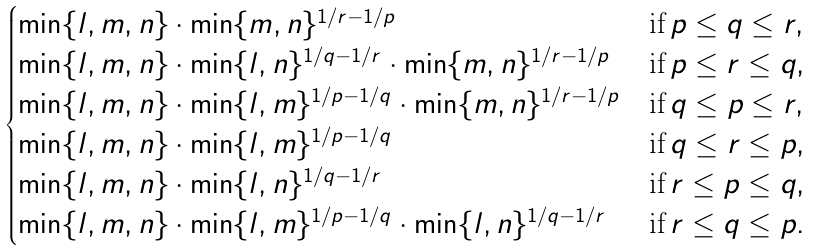<formula> <loc_0><loc_0><loc_500><loc_500>\begin{cases} \min \{ l , m , n \} \cdot \min \{ m , n \} ^ { 1 / r - 1 / p } & \text {if} \, p \leq q \leq r , \\ \min \{ l , m , n \} \cdot \min \{ l , n \} ^ { 1 / q - 1 / r } \cdot \min \{ m , n \} ^ { 1 / r - 1 / p } & \text {if} \, p \leq r \leq q , \\ \min \{ l , m , n \} \cdot \min \{ l , m \} ^ { 1 / p - 1 / q } \cdot \min \{ m , n \} ^ { 1 / r - 1 / p } & \text {if} \, q \leq p \leq r , \\ \min \{ l , m , n \} \cdot \min \{ l , m \} ^ { 1 / p - 1 / q } & \text {if} \, q \leq r \leq p , \\ \min \{ l , m , n \} \cdot \min \{ l , n \} ^ { 1 / q - 1 / r } & \text {if} \, r \leq p \leq q , \\ \min \{ l , m , n \} \cdot \min \{ l , m \} ^ { 1 / p - 1 / q } \cdot \min \{ l , n \} ^ { 1 / q - 1 / r } & \text {if} \, r \leq q \leq p . \end{cases}</formula> 